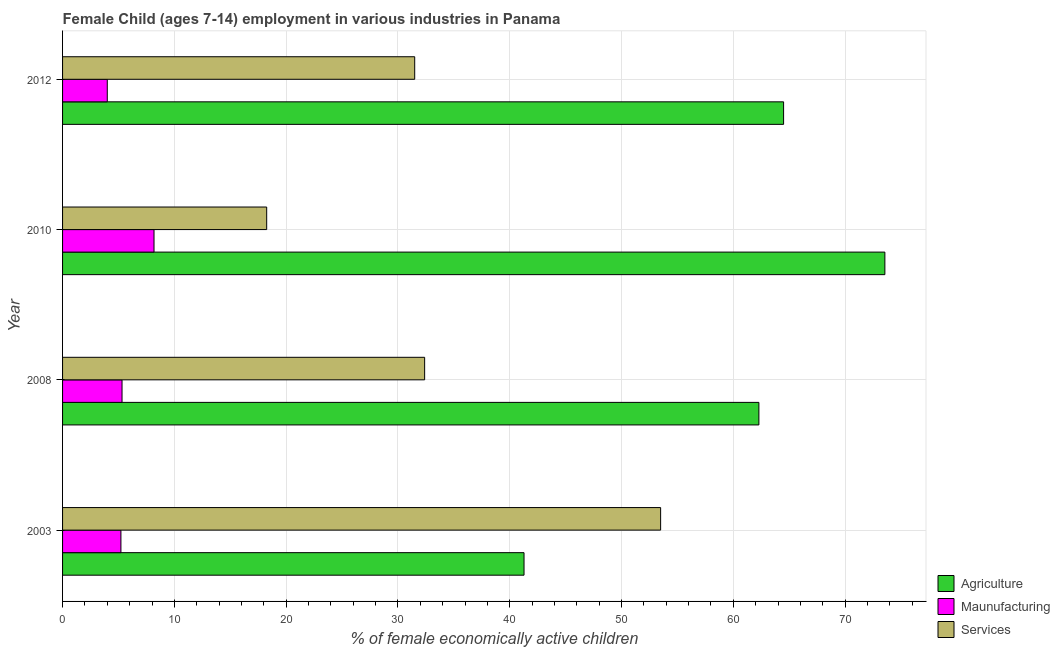How many different coloured bars are there?
Provide a short and direct response. 3. How many groups of bars are there?
Give a very brief answer. 4. Are the number of bars on each tick of the Y-axis equal?
Make the answer very short. Yes. How many bars are there on the 3rd tick from the top?
Offer a terse response. 3. How many bars are there on the 4th tick from the bottom?
Offer a terse response. 3. In how many cases, is the number of bars for a given year not equal to the number of legend labels?
Offer a very short reply. 0. What is the percentage of economically active children in agriculture in 2008?
Keep it short and to the point. 62.29. Across all years, what is the maximum percentage of economically active children in agriculture?
Provide a short and direct response. 73.56. Across all years, what is the minimum percentage of economically active children in agriculture?
Keep it short and to the point. 41.28. In which year was the percentage of economically active children in agriculture minimum?
Your response must be concise. 2003. What is the total percentage of economically active children in agriculture in the graph?
Provide a short and direct response. 241.63. What is the difference between the percentage of economically active children in agriculture in 2008 and that in 2012?
Offer a very short reply. -2.21. What is the difference between the percentage of economically active children in manufacturing in 2003 and the percentage of economically active children in services in 2012?
Ensure brevity in your answer.  -26.28. What is the average percentage of economically active children in services per year?
Keep it short and to the point. 33.91. In the year 2012, what is the difference between the percentage of economically active children in manufacturing and percentage of economically active children in agriculture?
Your answer should be compact. -60.5. What is the ratio of the percentage of economically active children in services in 2003 to that in 2010?
Your answer should be very brief. 2.93. Is the percentage of economically active children in services in 2003 less than that in 2012?
Provide a short and direct response. No. Is the difference between the percentage of economically active children in services in 2003 and 2012 greater than the difference between the percentage of economically active children in manufacturing in 2003 and 2012?
Provide a short and direct response. Yes. What is the difference between the highest and the second highest percentage of economically active children in services?
Your response must be concise. 21.11. What is the difference between the highest and the lowest percentage of economically active children in agriculture?
Make the answer very short. 32.28. What does the 3rd bar from the top in 2008 represents?
Your answer should be compact. Agriculture. What does the 1st bar from the bottom in 2003 represents?
Your answer should be compact. Agriculture. Is it the case that in every year, the sum of the percentage of economically active children in agriculture and percentage of economically active children in manufacturing is greater than the percentage of economically active children in services?
Your response must be concise. No. Are all the bars in the graph horizontal?
Make the answer very short. Yes. How many years are there in the graph?
Provide a succinct answer. 4. Are the values on the major ticks of X-axis written in scientific E-notation?
Keep it short and to the point. No. Does the graph contain grids?
Your response must be concise. Yes. Where does the legend appear in the graph?
Give a very brief answer. Bottom right. What is the title of the graph?
Your response must be concise. Female Child (ages 7-14) employment in various industries in Panama. What is the label or title of the X-axis?
Give a very brief answer. % of female economically active children. What is the label or title of the Y-axis?
Your response must be concise. Year. What is the % of female economically active children of Agriculture in 2003?
Make the answer very short. 41.28. What is the % of female economically active children of Maunufacturing in 2003?
Your answer should be compact. 5.22. What is the % of female economically active children of Services in 2003?
Make the answer very short. 53.5. What is the % of female economically active children in Agriculture in 2008?
Offer a very short reply. 62.29. What is the % of female economically active children in Maunufacturing in 2008?
Offer a terse response. 5.32. What is the % of female economically active children in Services in 2008?
Offer a very short reply. 32.39. What is the % of female economically active children of Agriculture in 2010?
Provide a short and direct response. 73.56. What is the % of female economically active children of Maunufacturing in 2010?
Your answer should be very brief. 8.18. What is the % of female economically active children in Services in 2010?
Keep it short and to the point. 18.26. What is the % of female economically active children in Agriculture in 2012?
Provide a succinct answer. 64.5. What is the % of female economically active children in Services in 2012?
Ensure brevity in your answer.  31.5. Across all years, what is the maximum % of female economically active children of Agriculture?
Your answer should be very brief. 73.56. Across all years, what is the maximum % of female economically active children in Maunufacturing?
Give a very brief answer. 8.18. Across all years, what is the maximum % of female economically active children in Services?
Offer a very short reply. 53.5. Across all years, what is the minimum % of female economically active children of Agriculture?
Offer a terse response. 41.28. Across all years, what is the minimum % of female economically active children of Maunufacturing?
Ensure brevity in your answer.  4. Across all years, what is the minimum % of female economically active children in Services?
Offer a very short reply. 18.26. What is the total % of female economically active children of Agriculture in the graph?
Offer a terse response. 241.63. What is the total % of female economically active children in Maunufacturing in the graph?
Ensure brevity in your answer.  22.72. What is the total % of female economically active children of Services in the graph?
Ensure brevity in your answer.  135.65. What is the difference between the % of female economically active children in Agriculture in 2003 and that in 2008?
Offer a terse response. -21.01. What is the difference between the % of female economically active children of Services in 2003 and that in 2008?
Your response must be concise. 21.11. What is the difference between the % of female economically active children of Agriculture in 2003 and that in 2010?
Offer a very short reply. -32.28. What is the difference between the % of female economically active children of Maunufacturing in 2003 and that in 2010?
Your answer should be very brief. -2.96. What is the difference between the % of female economically active children in Services in 2003 and that in 2010?
Keep it short and to the point. 35.24. What is the difference between the % of female economically active children of Agriculture in 2003 and that in 2012?
Offer a very short reply. -23.22. What is the difference between the % of female economically active children in Maunufacturing in 2003 and that in 2012?
Offer a terse response. 1.22. What is the difference between the % of female economically active children of Agriculture in 2008 and that in 2010?
Make the answer very short. -11.27. What is the difference between the % of female economically active children in Maunufacturing in 2008 and that in 2010?
Provide a short and direct response. -2.86. What is the difference between the % of female economically active children in Services in 2008 and that in 2010?
Offer a very short reply. 14.13. What is the difference between the % of female economically active children of Agriculture in 2008 and that in 2012?
Make the answer very short. -2.21. What is the difference between the % of female economically active children of Maunufacturing in 2008 and that in 2012?
Offer a very short reply. 1.32. What is the difference between the % of female economically active children of Services in 2008 and that in 2012?
Your response must be concise. 0.89. What is the difference between the % of female economically active children in Agriculture in 2010 and that in 2012?
Your response must be concise. 9.06. What is the difference between the % of female economically active children of Maunufacturing in 2010 and that in 2012?
Give a very brief answer. 4.18. What is the difference between the % of female economically active children of Services in 2010 and that in 2012?
Your answer should be very brief. -13.24. What is the difference between the % of female economically active children of Agriculture in 2003 and the % of female economically active children of Maunufacturing in 2008?
Offer a terse response. 35.96. What is the difference between the % of female economically active children of Agriculture in 2003 and the % of female economically active children of Services in 2008?
Your response must be concise. 8.89. What is the difference between the % of female economically active children in Maunufacturing in 2003 and the % of female economically active children in Services in 2008?
Offer a terse response. -27.17. What is the difference between the % of female economically active children of Agriculture in 2003 and the % of female economically active children of Maunufacturing in 2010?
Your answer should be compact. 33.1. What is the difference between the % of female economically active children in Agriculture in 2003 and the % of female economically active children in Services in 2010?
Give a very brief answer. 23.02. What is the difference between the % of female economically active children of Maunufacturing in 2003 and the % of female economically active children of Services in 2010?
Your response must be concise. -13.04. What is the difference between the % of female economically active children of Agriculture in 2003 and the % of female economically active children of Maunufacturing in 2012?
Give a very brief answer. 37.28. What is the difference between the % of female economically active children in Agriculture in 2003 and the % of female economically active children in Services in 2012?
Keep it short and to the point. 9.78. What is the difference between the % of female economically active children of Maunufacturing in 2003 and the % of female economically active children of Services in 2012?
Make the answer very short. -26.28. What is the difference between the % of female economically active children of Agriculture in 2008 and the % of female economically active children of Maunufacturing in 2010?
Your answer should be very brief. 54.11. What is the difference between the % of female economically active children of Agriculture in 2008 and the % of female economically active children of Services in 2010?
Your answer should be very brief. 44.03. What is the difference between the % of female economically active children in Maunufacturing in 2008 and the % of female economically active children in Services in 2010?
Your answer should be compact. -12.94. What is the difference between the % of female economically active children of Agriculture in 2008 and the % of female economically active children of Maunufacturing in 2012?
Offer a terse response. 58.29. What is the difference between the % of female economically active children of Agriculture in 2008 and the % of female economically active children of Services in 2012?
Provide a succinct answer. 30.79. What is the difference between the % of female economically active children of Maunufacturing in 2008 and the % of female economically active children of Services in 2012?
Your answer should be very brief. -26.18. What is the difference between the % of female economically active children of Agriculture in 2010 and the % of female economically active children of Maunufacturing in 2012?
Provide a short and direct response. 69.56. What is the difference between the % of female economically active children of Agriculture in 2010 and the % of female economically active children of Services in 2012?
Offer a very short reply. 42.06. What is the difference between the % of female economically active children in Maunufacturing in 2010 and the % of female economically active children in Services in 2012?
Your answer should be very brief. -23.32. What is the average % of female economically active children of Agriculture per year?
Offer a terse response. 60.41. What is the average % of female economically active children in Maunufacturing per year?
Keep it short and to the point. 5.68. What is the average % of female economically active children of Services per year?
Ensure brevity in your answer.  33.91. In the year 2003, what is the difference between the % of female economically active children of Agriculture and % of female economically active children of Maunufacturing?
Give a very brief answer. 36.06. In the year 2003, what is the difference between the % of female economically active children in Agriculture and % of female economically active children in Services?
Provide a succinct answer. -12.22. In the year 2003, what is the difference between the % of female economically active children of Maunufacturing and % of female economically active children of Services?
Ensure brevity in your answer.  -48.28. In the year 2008, what is the difference between the % of female economically active children of Agriculture and % of female economically active children of Maunufacturing?
Your response must be concise. 56.97. In the year 2008, what is the difference between the % of female economically active children of Agriculture and % of female economically active children of Services?
Your answer should be compact. 29.9. In the year 2008, what is the difference between the % of female economically active children of Maunufacturing and % of female economically active children of Services?
Ensure brevity in your answer.  -27.07. In the year 2010, what is the difference between the % of female economically active children of Agriculture and % of female economically active children of Maunufacturing?
Your answer should be compact. 65.38. In the year 2010, what is the difference between the % of female economically active children in Agriculture and % of female economically active children in Services?
Provide a short and direct response. 55.3. In the year 2010, what is the difference between the % of female economically active children in Maunufacturing and % of female economically active children in Services?
Your response must be concise. -10.08. In the year 2012, what is the difference between the % of female economically active children of Agriculture and % of female economically active children of Maunufacturing?
Provide a succinct answer. 60.5. In the year 2012, what is the difference between the % of female economically active children in Maunufacturing and % of female economically active children in Services?
Make the answer very short. -27.5. What is the ratio of the % of female economically active children of Agriculture in 2003 to that in 2008?
Offer a very short reply. 0.66. What is the ratio of the % of female economically active children of Maunufacturing in 2003 to that in 2008?
Your answer should be compact. 0.98. What is the ratio of the % of female economically active children in Services in 2003 to that in 2008?
Give a very brief answer. 1.65. What is the ratio of the % of female economically active children in Agriculture in 2003 to that in 2010?
Ensure brevity in your answer.  0.56. What is the ratio of the % of female economically active children in Maunufacturing in 2003 to that in 2010?
Your answer should be compact. 0.64. What is the ratio of the % of female economically active children of Services in 2003 to that in 2010?
Provide a short and direct response. 2.93. What is the ratio of the % of female economically active children in Agriculture in 2003 to that in 2012?
Provide a succinct answer. 0.64. What is the ratio of the % of female economically active children in Maunufacturing in 2003 to that in 2012?
Offer a very short reply. 1.3. What is the ratio of the % of female economically active children in Services in 2003 to that in 2012?
Provide a short and direct response. 1.7. What is the ratio of the % of female economically active children of Agriculture in 2008 to that in 2010?
Offer a very short reply. 0.85. What is the ratio of the % of female economically active children of Maunufacturing in 2008 to that in 2010?
Your response must be concise. 0.65. What is the ratio of the % of female economically active children of Services in 2008 to that in 2010?
Make the answer very short. 1.77. What is the ratio of the % of female economically active children in Agriculture in 2008 to that in 2012?
Your response must be concise. 0.97. What is the ratio of the % of female economically active children in Maunufacturing in 2008 to that in 2012?
Keep it short and to the point. 1.33. What is the ratio of the % of female economically active children of Services in 2008 to that in 2012?
Provide a succinct answer. 1.03. What is the ratio of the % of female economically active children of Agriculture in 2010 to that in 2012?
Provide a succinct answer. 1.14. What is the ratio of the % of female economically active children of Maunufacturing in 2010 to that in 2012?
Ensure brevity in your answer.  2.04. What is the ratio of the % of female economically active children of Services in 2010 to that in 2012?
Provide a short and direct response. 0.58. What is the difference between the highest and the second highest % of female economically active children of Agriculture?
Keep it short and to the point. 9.06. What is the difference between the highest and the second highest % of female economically active children of Maunufacturing?
Make the answer very short. 2.86. What is the difference between the highest and the second highest % of female economically active children of Services?
Give a very brief answer. 21.11. What is the difference between the highest and the lowest % of female economically active children of Agriculture?
Give a very brief answer. 32.28. What is the difference between the highest and the lowest % of female economically active children of Maunufacturing?
Your response must be concise. 4.18. What is the difference between the highest and the lowest % of female economically active children in Services?
Provide a short and direct response. 35.24. 